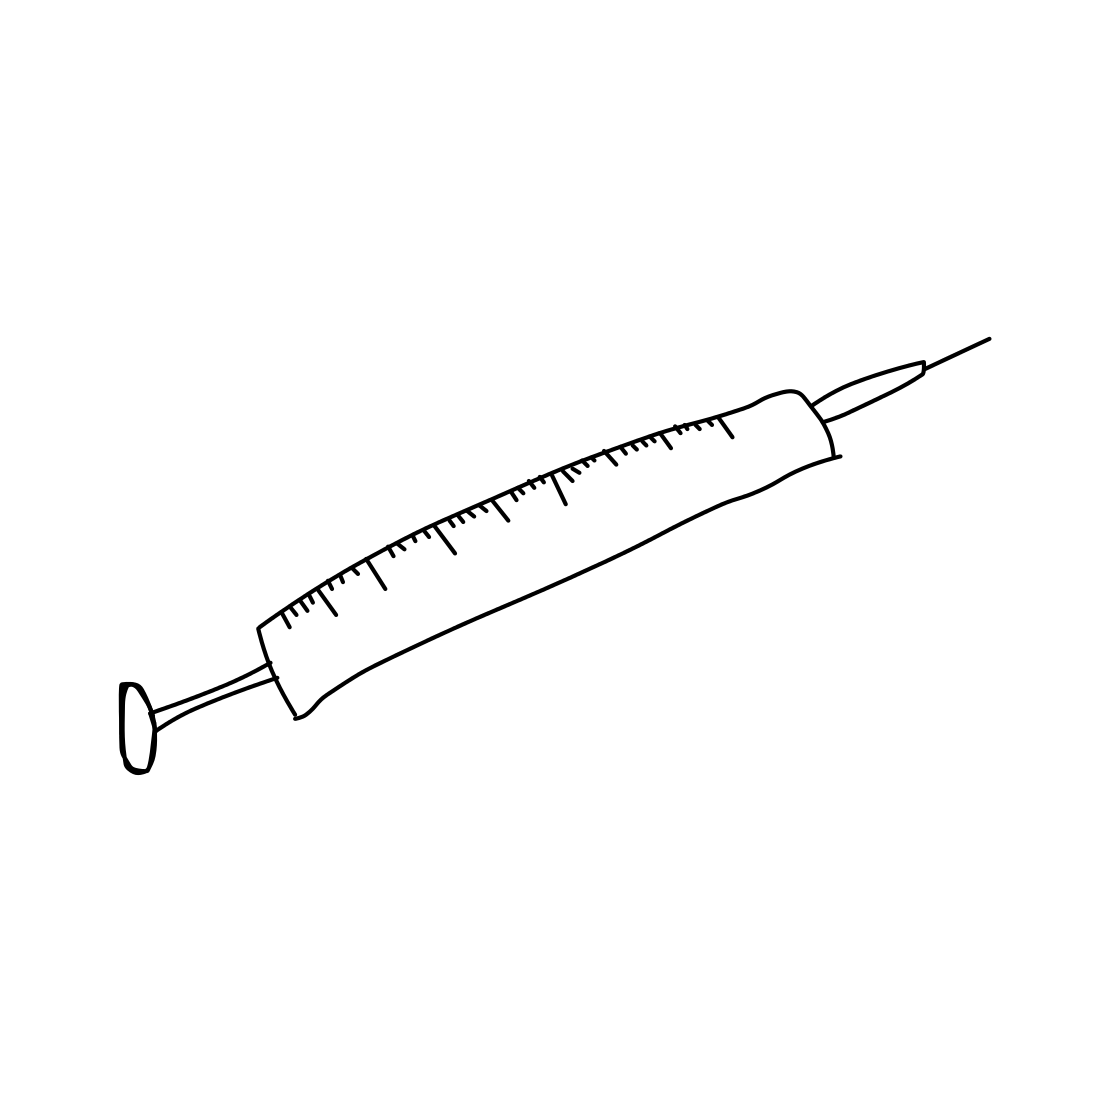Can you tell me more about the history and evolution of the syringe? Certainly! The syringe has a fascinating history that dates back to the 9th century when an Egyptian surgeon created a hollow glass tube to irrigate wounds. However, the modern hypodermic syringe, similar to the one sketched here, was developed in the mid-19th century. This innovation greatly improved medical capabilities by allowing for the precise delivery of medicines into the body and has evolved over time into various forms including disposable and insulin syringes, each serving a specific purpose in healthcare. 